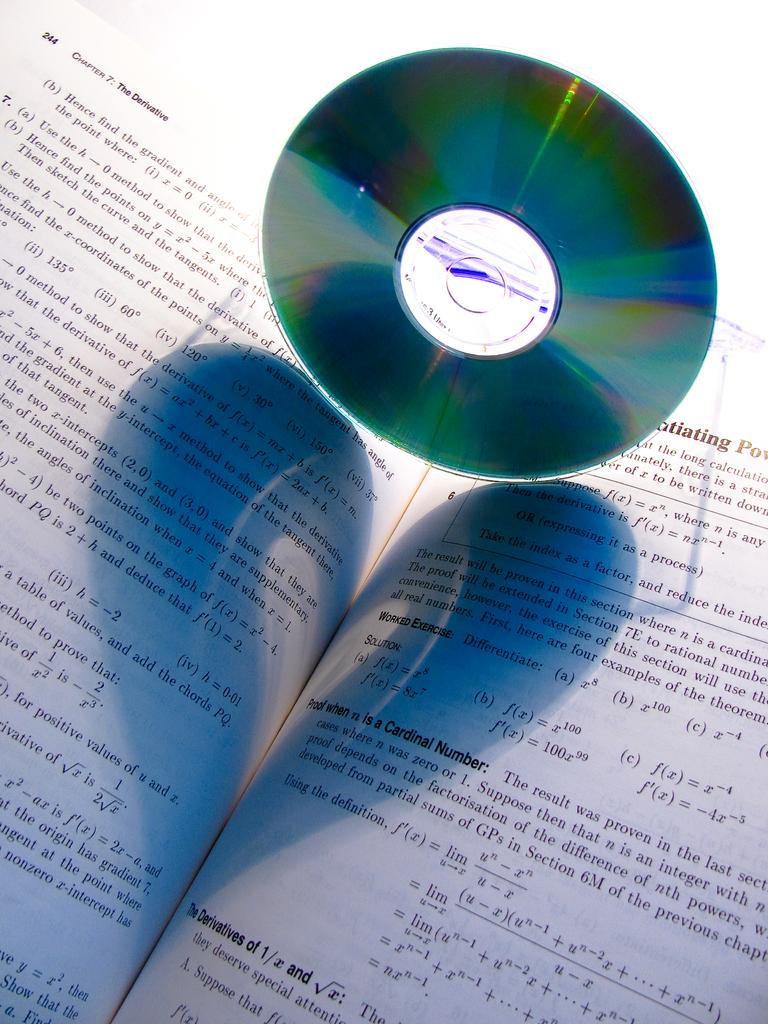<image>
Describe the image concisely. A CD is resting on a math book that is open to chapter 7. 